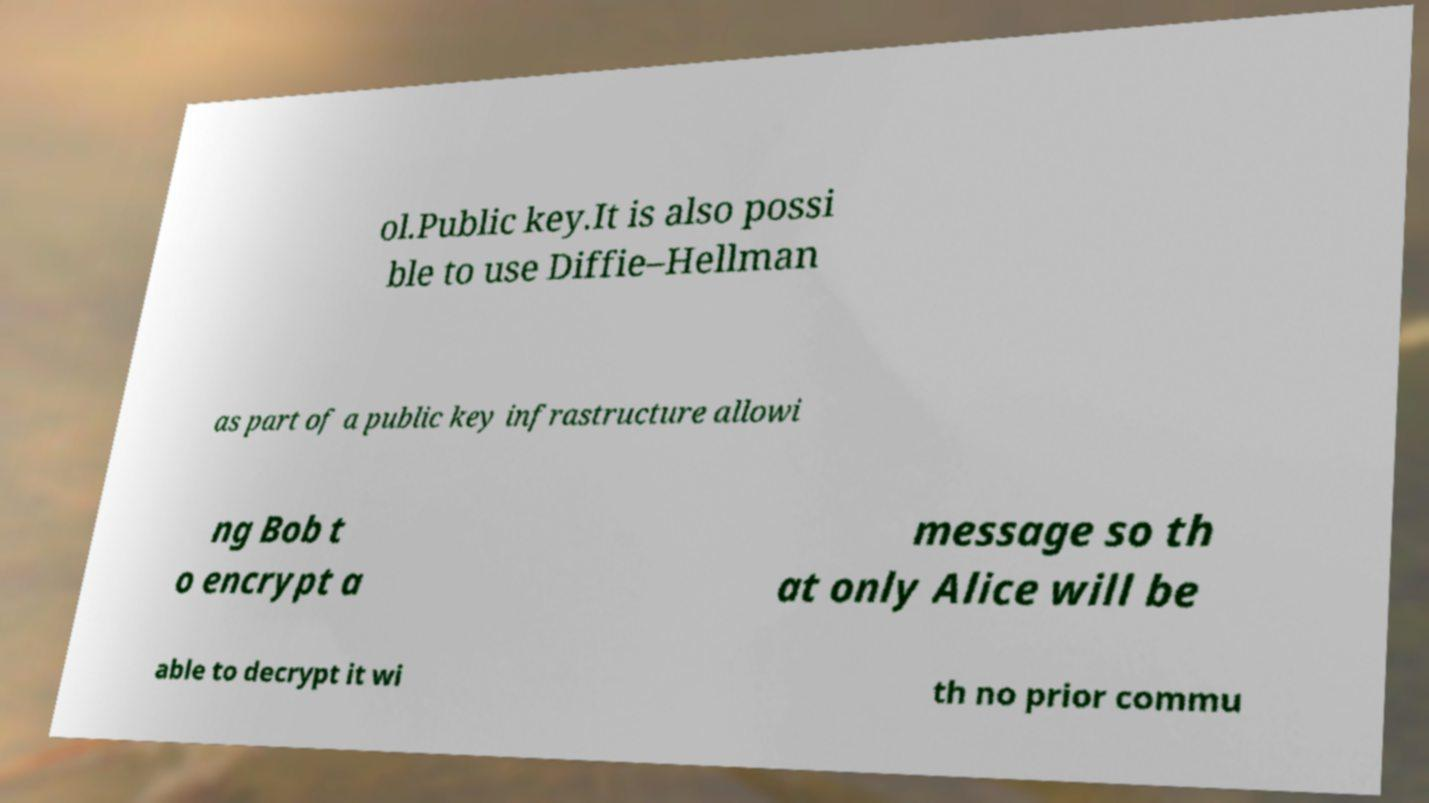For documentation purposes, I need the text within this image transcribed. Could you provide that? ol.Public key.It is also possi ble to use Diffie–Hellman as part of a public key infrastructure allowi ng Bob t o encrypt a message so th at only Alice will be able to decrypt it wi th no prior commu 